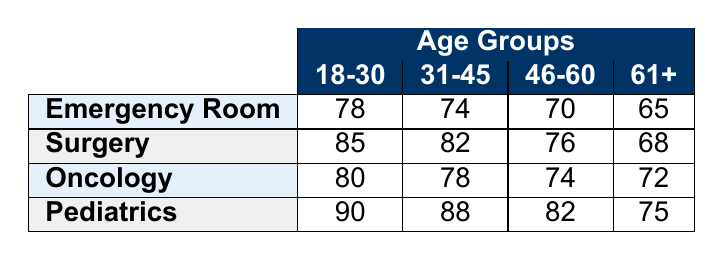What is the patient satisfaction score for the Emergency Room for the age group 31-45? The table shows that for the Emergency Room department, the satisfaction score for the age group 31-45 is located under the corresponding column, which indicates a score of 74.
Answer: 74 What is the lowest patient satisfaction score in the Pediatrics department? Looking at the Pediatrics row in the table, the satisfaction scores listed are 90, 88, 82, and 75. The lowest score is the last one, which is 75.
Answer: 75 What is the difference between the highest and lowest satisfaction scores in the Surgery department? In the Surgery department, the satisfaction scores are 85, 82, 76, and 68. The highest score is 85, and the lowest score is 68. The difference is calculated by subtracting the lowest score from the highest score: 85 - 68 = 17.
Answer: 17 Which department has the highest satisfaction score for the age group 61+? In the 61+ age group, the satisfaction scores for each department are as follows: Emergency Room (65), Surgery (68), Oncology (72), and Pediatrics (75). Among these scores, Pediatrics has the highest score of 75.
Answer: Pediatrics Are the majority of the departments scoring above 75 for the age group 18-30? The scores for the age group 18-30 are: Emergency Room (78), Surgery (85), Oncology (80), and Pediatrics (90). All these scores are above 75, indicating that the majority are indeed scoring above this threshold.
Answer: Yes What is the average patient satisfaction score for the Oncology department across all age groups? The Oncology scores for each age group are 80, 78, 74, and 72. To find the average, sum these scores: 80 + 78 + 74 + 72 = 304. Then divide by the number of age groups, which is 4: 304 / 4 = 76.
Answer: 76 Which age group has the highest overall patient satisfaction across all departments? By reviewing the scores across all departments for each age group, we have: 18-30 (78 + 85 + 80 + 90 = 333), 31-45 (74 + 82 + 78 + 88 = 322), 46-60 (70 + 76 + 74 + 82 = 302), and 61+ (65 + 68 + 72 + 75 = 280). The 18-30 age group has the highest total score of 333.
Answer: 18-30 What is the satisfaction score for the 46-60 age group in the Emergency Room? Referring to the Emergency Room row for the 46-60 age group, the satisfaction score listed is 70.
Answer: 70 